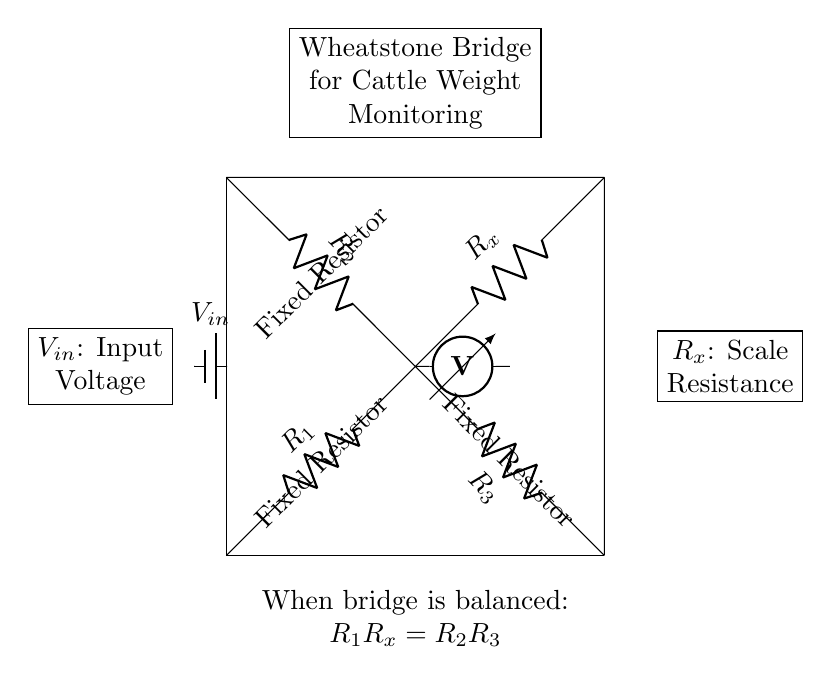What type of circuit is represented here? The circuit is a Wheatstone bridge, which is used to measure unknown resistances by balancing two legs of a bridge circuit.
Answer: Wheatstone bridge What components are used for the resistors? The circuit shows four resistors: R1, R2, R3, and Rx. R1, R2, and R3 are fixed resistors, while Rx is the unknown resistance to be measured.
Answer: R1, R2, R3, Rx What is the significance of the voltmeter in the circuit? The voltmeter measures the potential difference between the two points at which it is connected, which indicates whether the bridge is balanced or unbalanced.
Answer: Measures voltage What condition must be satisfied for the bridge to be balanced? The condition is that the product of R1 and Rx must equal the product of R2 and R3 (R1Rx = R2R3). This indicates that the voltage across the voltmeter will be zero when balanced.
Answer: R1Rx = R2R3 What does the battery represent in the circuit? The battery provides the input voltage, which is essential for the operation of the Wheatstone bridge, allowing current to flow through the circuit.
Answer: Input voltage How does the Wheatstone bridge help in monitoring cattle weight? By measuring the resistance Rx of the scale, which changes when cattle step on it, the bridge calculates their weight based on the known values of R1, R2, and R3.
Answer: Measures weight 